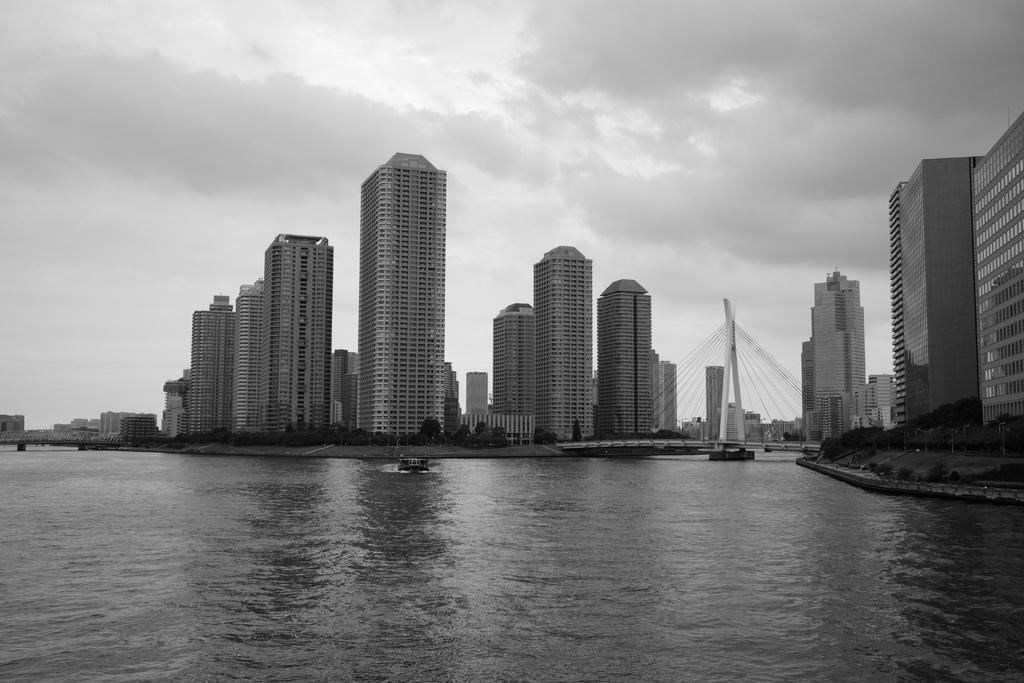What is the color scheme of the image? The image is black and white. What can be seen on the water in the image? There are boats on the water in the image. What is visible in the background of the image? Buildings, clouds, and a bridge are visible in the background of the image. What type of school can be seen in the image? There is no school present in the image; it features boats on the water, buildings, clouds, and a bridge in the background. Can you tell me what the cook is preparing in the image? There is no cook or any food preparation visible in the image. 